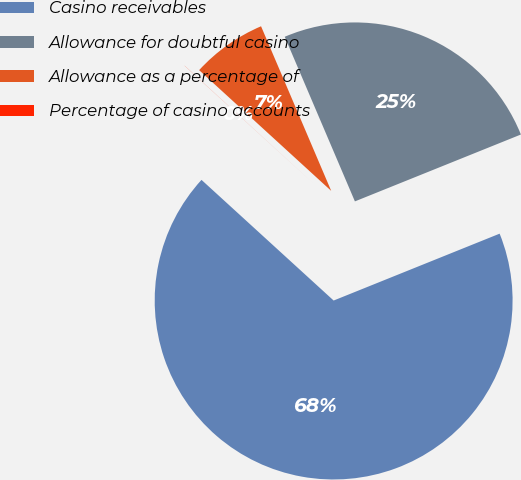Convert chart to OTSL. <chart><loc_0><loc_0><loc_500><loc_500><pie_chart><fcel>Casino receivables<fcel>Allowance for doubtful casino<fcel>Allowance as a percentage of<fcel>Percentage of casino accounts<nl><fcel>67.88%<fcel>25.32%<fcel>6.8%<fcel>0.01%<nl></chart> 